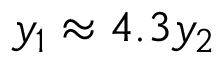<formula> <loc_0><loc_0><loc_500><loc_500>y _ { 1 } \approx 4 . 3 y _ { 2 }</formula> 